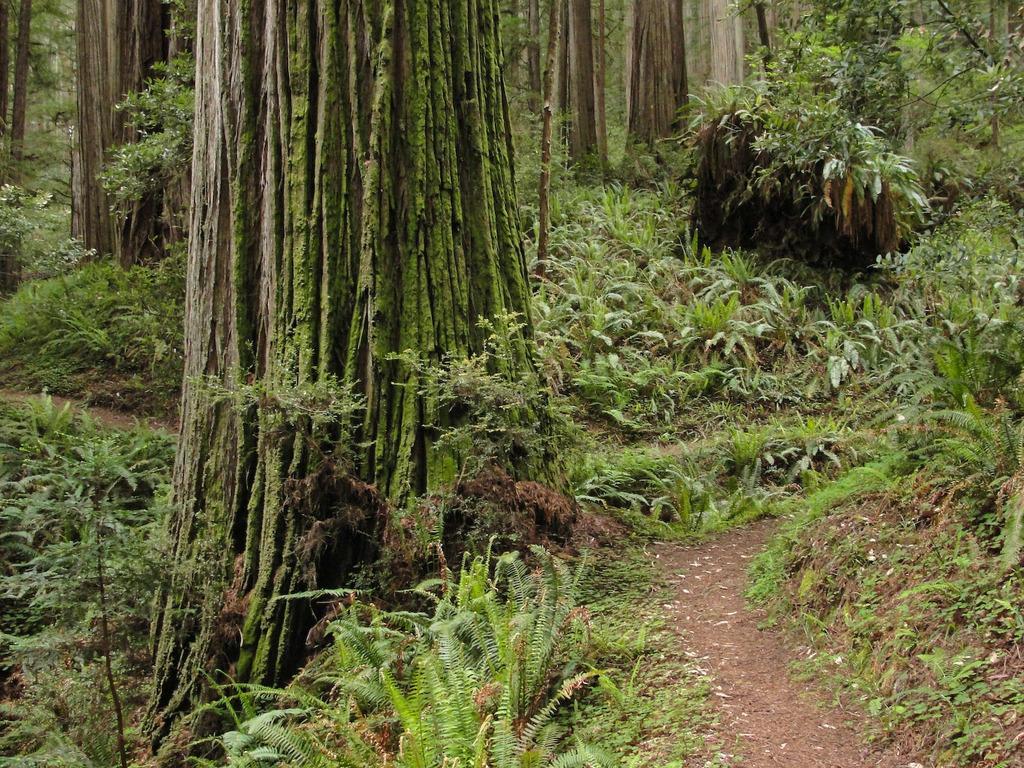Please provide a concise description of this image. In this image, we can see trees and plants. At the bottom, there is ground. 